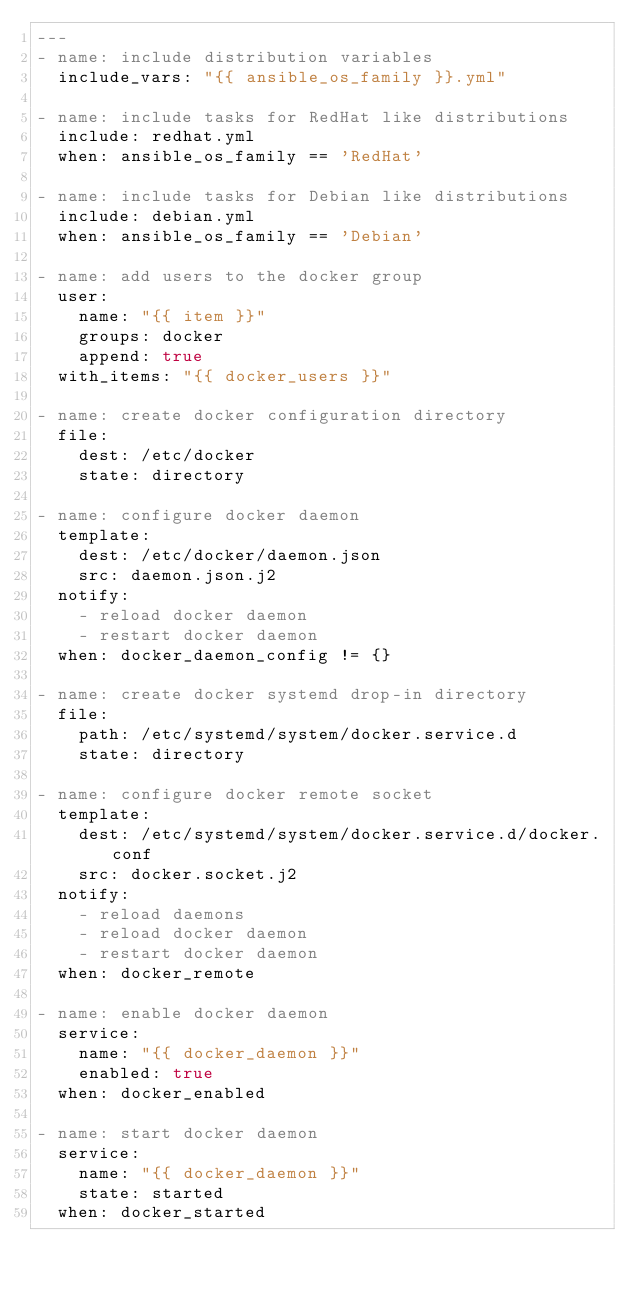<code> <loc_0><loc_0><loc_500><loc_500><_YAML_>---
- name: include distribution variables
  include_vars: "{{ ansible_os_family }}.yml"

- name: include tasks for RedHat like distributions
  include: redhat.yml
  when: ansible_os_family == 'RedHat'

- name: include tasks for Debian like distributions
  include: debian.yml
  when: ansible_os_family == 'Debian'

- name: add users to the docker group
  user:
    name: "{{ item }}"
    groups: docker
    append: true
  with_items: "{{ docker_users }}"

- name: create docker configuration directory
  file:
    dest: /etc/docker
    state: directory

- name: configure docker daemon
  template:
    dest: /etc/docker/daemon.json
    src: daemon.json.j2
  notify:
    - reload docker daemon
    - restart docker daemon
  when: docker_daemon_config != {}

- name: create docker systemd drop-in directory
  file:
    path: /etc/systemd/system/docker.service.d
    state: directory

- name: configure docker remote socket
  template:
    dest: /etc/systemd/system/docker.service.d/docker.conf
    src: docker.socket.j2
  notify:
    - reload daemons
    - reload docker daemon
    - restart docker daemon
  when: docker_remote

- name: enable docker daemon
  service:
    name: "{{ docker_daemon }}"
    enabled: true
  when: docker_enabled

- name: start docker daemon
  service:
    name: "{{ docker_daemon }}"
    state: started
  when: docker_started
</code> 